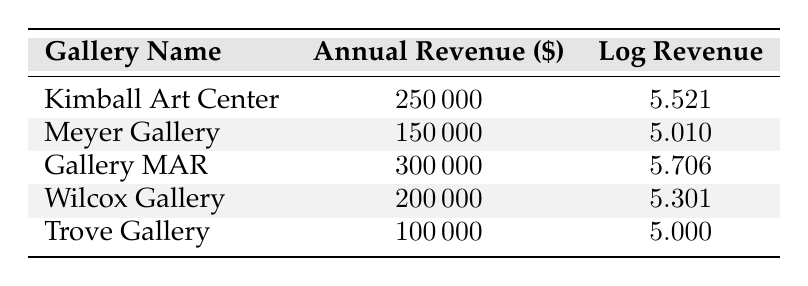What is the annual revenue of Gallery MAR? The table directly lists the annual revenue for each gallery. For Gallery MAR, the annual revenue is specified as 300000.
Answer: 300000 Which gallery has the lowest annual revenue? To find the gallery with the lowest revenue, we compare the annual revenue values in the table. The lowest revenue is for Trove Gallery at 100000.
Answer: Trove Gallery What is the total annual revenue of all galleries combined? To find the total annual revenue, we sum the annual revenues for all galleries: 250000 + 150000 + 300000 + 200000 + 100000 = 1000000.
Answer: 1000000 Is the annual revenue of the Kimball Art Center greater than that of the Wilcox Gallery? The annual revenue for Kimball Art Center is 250000, and for Wilcox Gallery, it is 200000. Since 250000 is greater than 200000, the statement is true.
Answer: Yes What is the average annual revenue of the galleries? To find the average, we take the total annual revenue (1000000) and divide it by the number of galleries (5): 1000000 / 5 = 200000.
Answer: 200000 How many galleries have an annual revenue above 200000? From the annual revenue values, we note that Gallery MAR (300000) and Kimball Art Center (250000) are above 200000. This gives us a total of 2 galleries.
Answer: 2 What is the difference in annual revenue between the Meyer Gallery and Trove Gallery? The annual revenue for Meyer Gallery is 150000 and for Trove Gallery it is 100000. Subtracting these gives: 150000 - 100000 = 50000.
Answer: 50000 Is the log revenue for Wilcox Gallery higher than 5.3? The log revenue for Wilcox Gallery is 5.301. Since 5.301 is not greater than 5.3, the answer is false.
Answer: No Which gallery has a log revenue closest to 5.5? Looking at the log revenue values, Kimball Art Center (5.521) has the closest log revenue to 5.5, compared to all others.
Answer: Kimball Art Center 